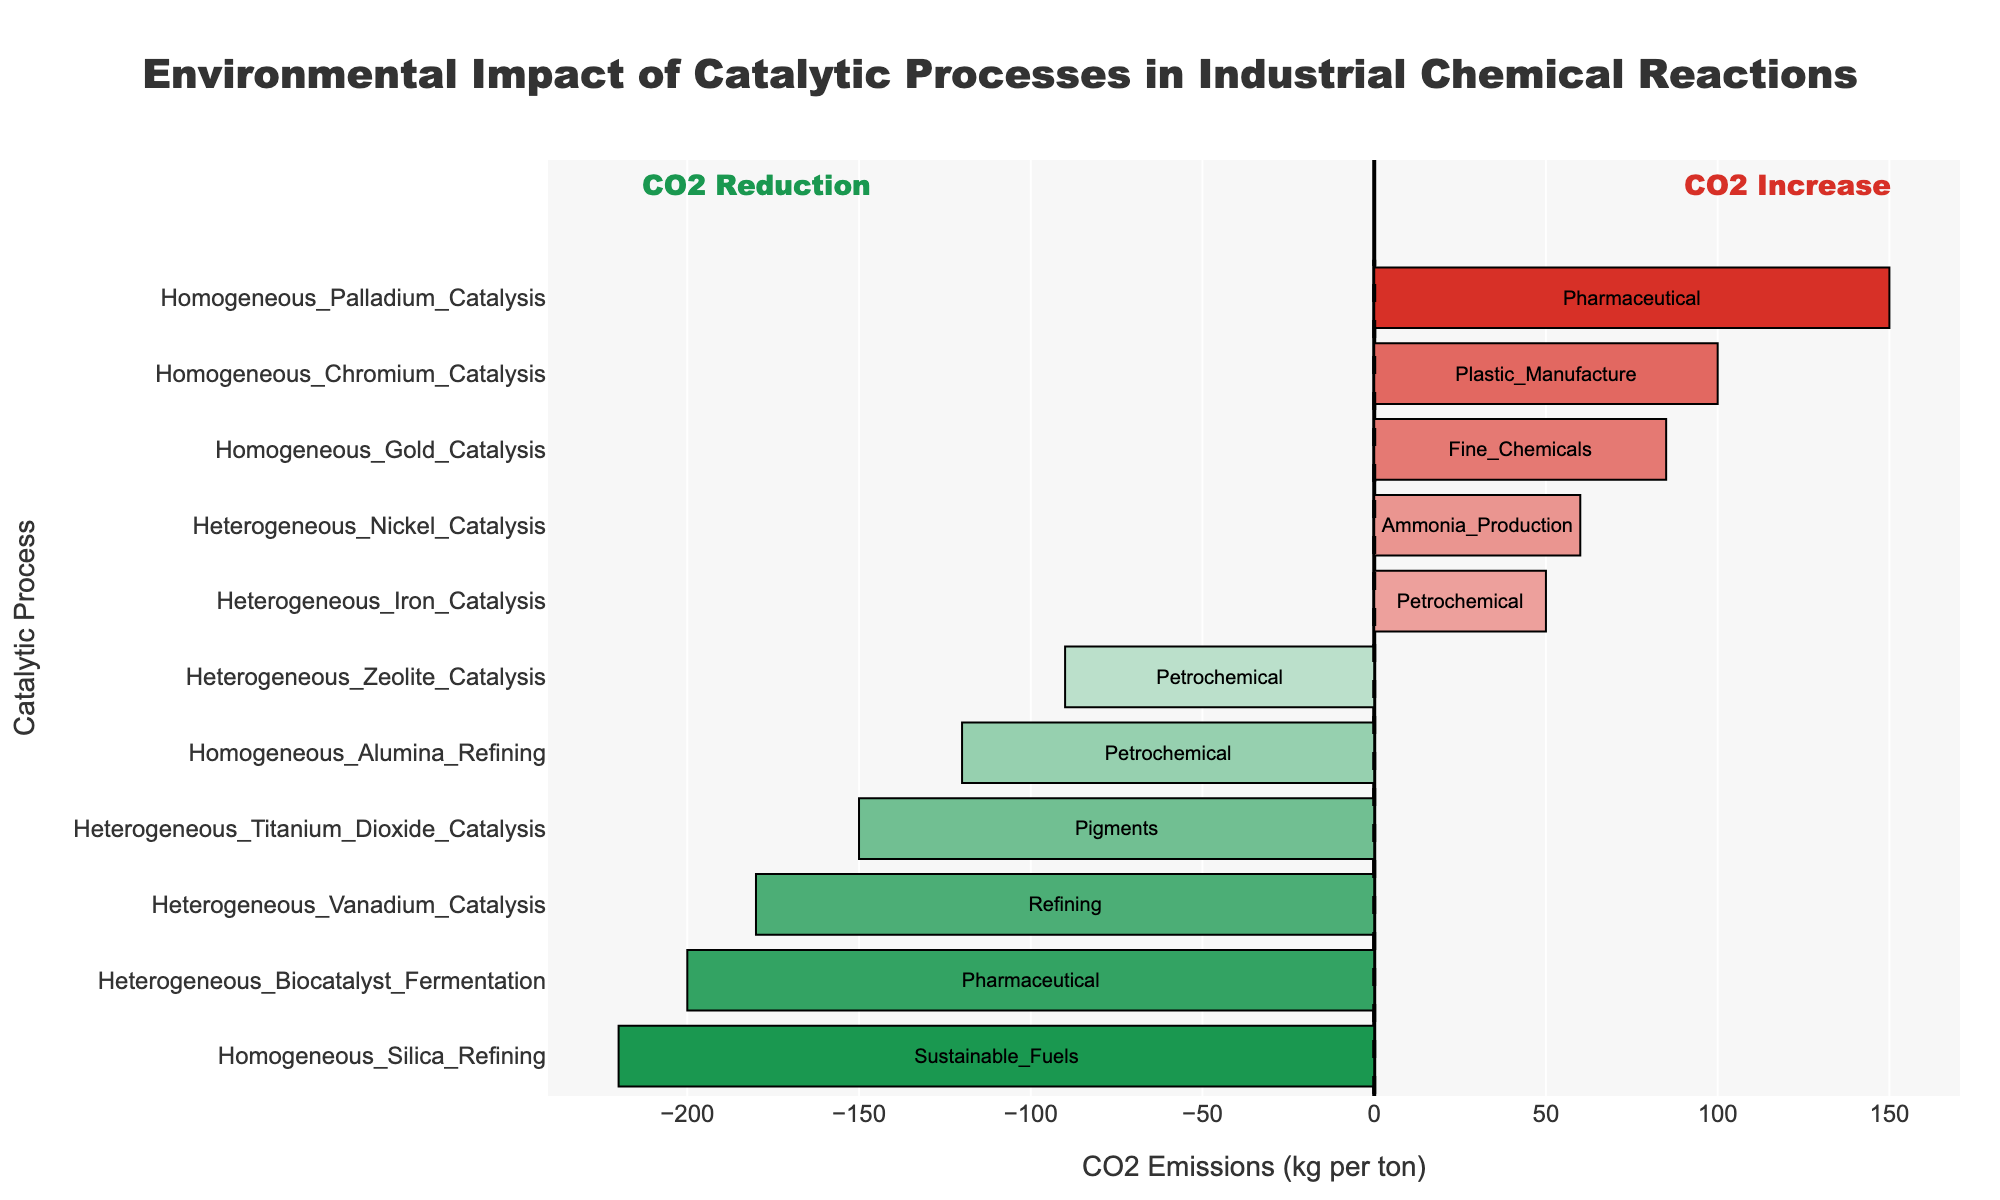Which catalytic process results in the greatest reduction in CO2 emissions? The bar with the most negative value indicates the greatest reduction in CO2 emissions. The "Homogeneous_Silica_Refining" process has the lowest CO2 emission value at -220 kg per ton.
Answer: Homogeneous_Silica_Refining Which industry is associated with the highest increase in CO2 emissions? The bar with the most positive value represents the highest CO2 emissions increase. "Homogeneous_Palladium_Catalysis" shows the highest increase with +150 kg per ton, which is in the Pharmaceutical industry.
Answer: Pharmaceutical How do the CO2 reductions in "Heterogeneous_Titanium_Dioxide_Catalysis" and "Heterogeneous_Vanadium_Catalysis" compare? Check the values corresponding to these processes. The CO2 reduction for "Heterogeneous_Titanium_Dioxide_Catalysis" is -150 kg per ton, whereas for "Heterogeneous_Vanadium_Catalysis" it's -180 kg per ton. "Heterogeneous_Vanadium_Catalysis" has a greater reduction.
Answer: Heterogeneous_Vanadium_Catalysis has greater reduction What is the average CO2 emission change for all Homogeneous catalytic processes? Identify and sum the CO2 emission values for all Homogeneous processes and divide by their count. (-120 + 150 + 100 + 85 -220) / 5 = -1 kg per ton
Answer: -1 kg per ton Which process in the Petrochemical industry leads to CO2 reduction? Look for processes in the Petrochemical industry with negative CO2 emission values. "Homogeneous_Alumina_Refining" and "Heterogeneous_Zeolite_Catalysis" show reductions.
Answer: Homogeneous_Alumina_Refining, Heterogeneous_Zeolite_Catalysis Which catalytic process in the Pharmaceutical industry results in the highest CO2 emissions? Among the processes in the Pharmaceutical industry, find those with highest CO2 emissions. "Homogeneous_Palladium_Catalysis" has the highest CO2 emission of +150 kg per ton.
Answer: Homogeneous_Palladium_Catalysis What is the total CO2 reduction for all heterogeneous catalytic processes in the dataset? Sum the CO2 emission values for all Heterogeneous processes with negative emissions: (-200 -180 -90 -150) = -620 kg per ton
Answer: -620 kg per ton How much more CO2 does the "Heterogeneous_Nickel_Catalysis" emit compared to the "Heterogeneous_Iron_Catalysis"? Subtract the emission value of "Heterogeneous_Iron_Catalysis" from "Heterogeneous_Nickel_Catalysis": 60 - 50 = 10 kg per ton.
Answer: 10 kg per ton Which catalytic process is used in the production of Sustainable Fuels, and what is its CO2 emission value? Identify the process corresponding to "Sustainable_Fuels." "Homogeneous_Silica_Refining" has a CO2 emission value of -220 kg per ton.
Answer: Homogeneous_Silica_Refining, -220 kg per ton 